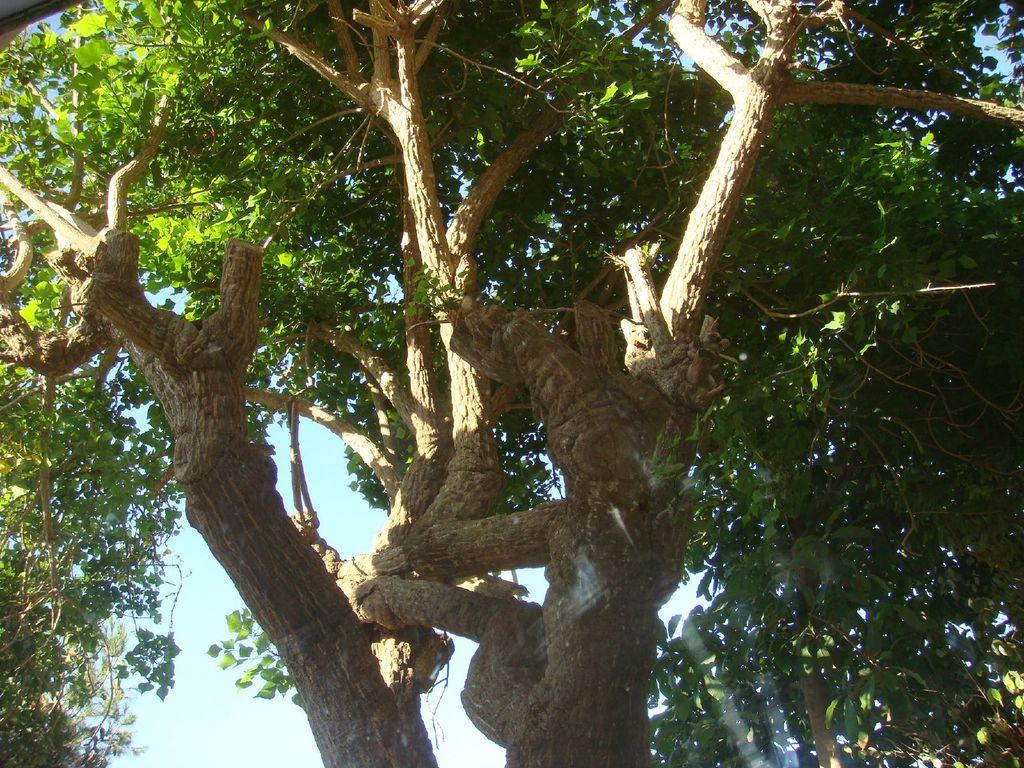What type of natural scenery can be seen in the background of the image? There are trees in the background of the image. What else is visible in the background of the image? The sky is visible in the background of the image. What is the caption of the image? There is no caption present in the image. What shape is the distance between the trees and the sky? The distance between the trees and the sky cannot be described as a shape, as it is a spatial relationship rather than a geometric form. 